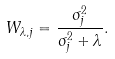<formula> <loc_0><loc_0><loc_500><loc_500>W _ { \lambda , j } = \frac { \sigma ^ { 2 } _ { j } } { \sigma ^ { 2 } _ { j } + \lambda } .</formula> 